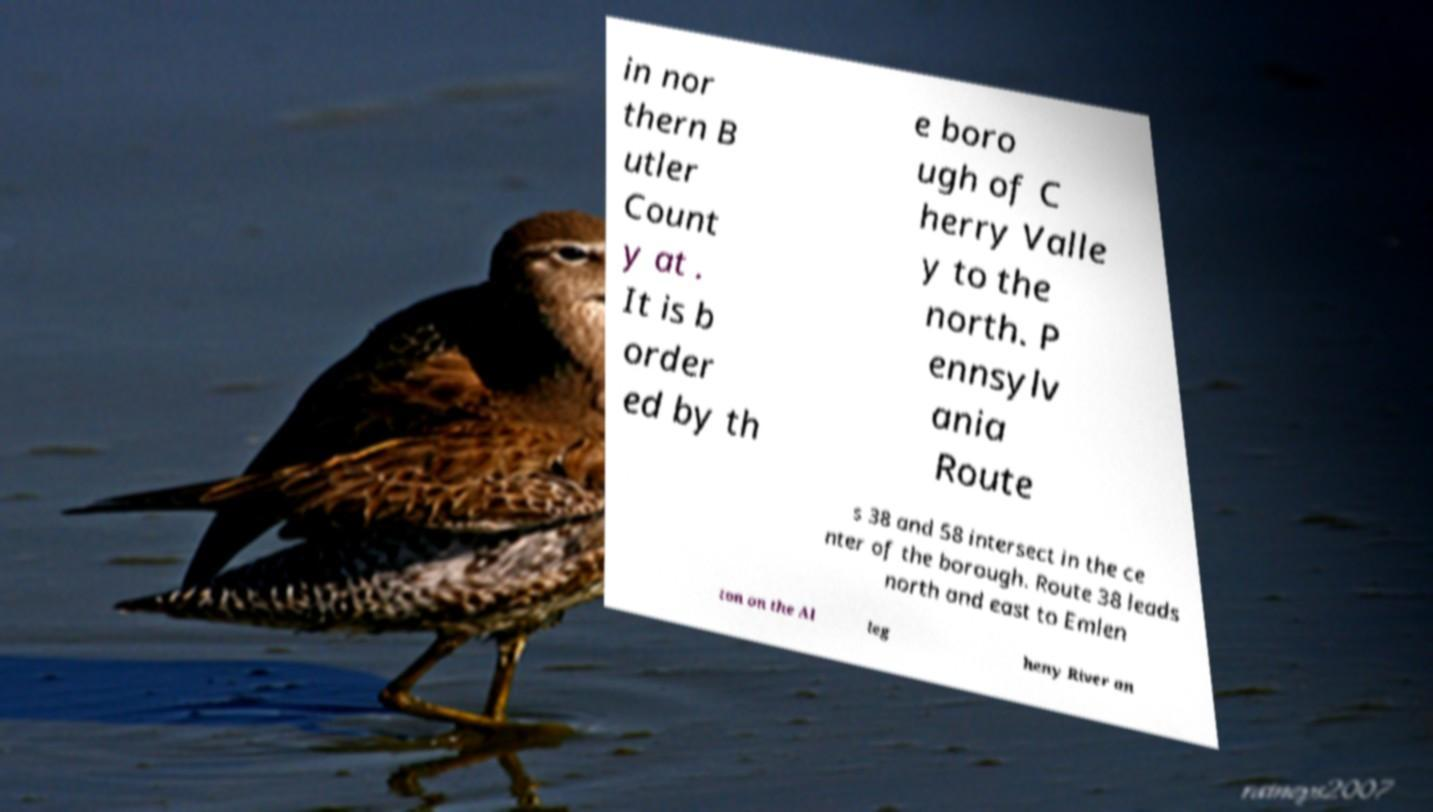Could you extract and type out the text from this image? in nor thern B utler Count y at . It is b order ed by th e boro ugh of C herry Valle y to the north. P ennsylv ania Route s 38 and 58 intersect in the ce nter of the borough. Route 38 leads north and east to Emlen ton on the Al leg heny River an 